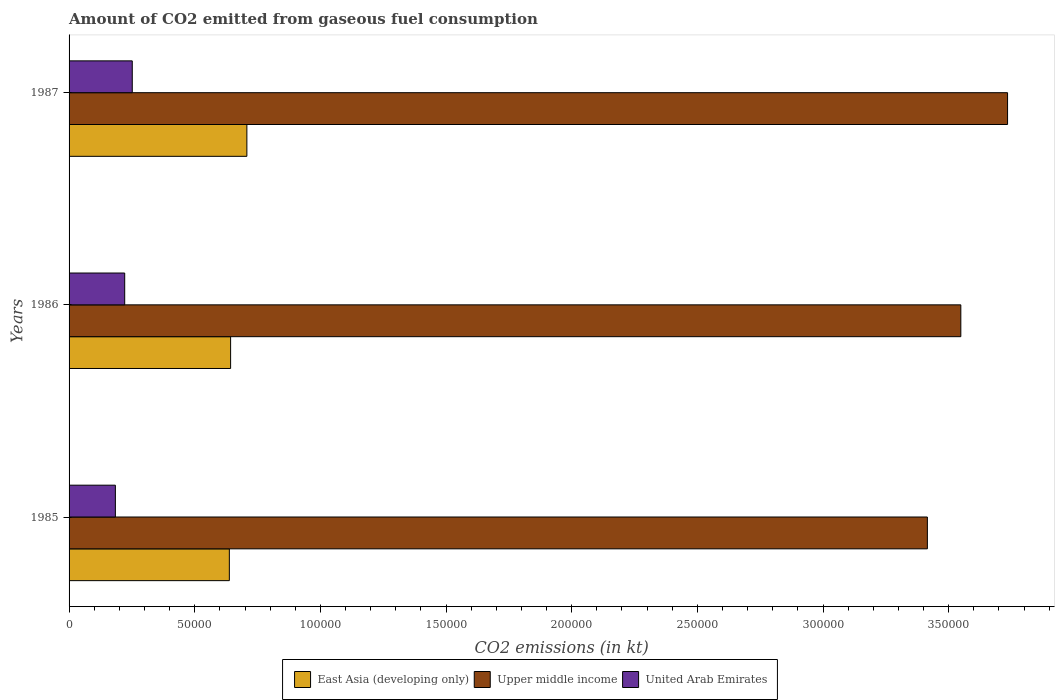How many groups of bars are there?
Make the answer very short. 3. Are the number of bars per tick equal to the number of legend labels?
Your response must be concise. Yes. How many bars are there on the 1st tick from the top?
Your answer should be very brief. 3. What is the label of the 2nd group of bars from the top?
Ensure brevity in your answer.  1986. In how many cases, is the number of bars for a given year not equal to the number of legend labels?
Provide a short and direct response. 0. What is the amount of CO2 emitted in East Asia (developing only) in 1987?
Provide a succinct answer. 7.07e+04. Across all years, what is the maximum amount of CO2 emitted in Upper middle income?
Your response must be concise. 3.73e+05. Across all years, what is the minimum amount of CO2 emitted in East Asia (developing only)?
Give a very brief answer. 6.38e+04. In which year was the amount of CO2 emitted in East Asia (developing only) maximum?
Provide a succinct answer. 1987. In which year was the amount of CO2 emitted in East Asia (developing only) minimum?
Your answer should be compact. 1985. What is the total amount of CO2 emitted in Upper middle income in the graph?
Your response must be concise. 1.07e+06. What is the difference between the amount of CO2 emitted in United Arab Emirates in 1986 and that in 1987?
Your response must be concise. -3006.94. What is the difference between the amount of CO2 emitted in Upper middle income in 1985 and the amount of CO2 emitted in United Arab Emirates in 1986?
Make the answer very short. 3.19e+05. What is the average amount of CO2 emitted in United Arab Emirates per year?
Offer a terse response. 2.19e+04. In the year 1987, what is the difference between the amount of CO2 emitted in United Arab Emirates and amount of CO2 emitted in Upper middle income?
Give a very brief answer. -3.48e+05. What is the ratio of the amount of CO2 emitted in East Asia (developing only) in 1985 to that in 1986?
Ensure brevity in your answer.  0.99. Is the difference between the amount of CO2 emitted in United Arab Emirates in 1986 and 1987 greater than the difference between the amount of CO2 emitted in Upper middle income in 1986 and 1987?
Your answer should be very brief. Yes. What is the difference between the highest and the second highest amount of CO2 emitted in East Asia (developing only)?
Provide a short and direct response. 6475.14. What is the difference between the highest and the lowest amount of CO2 emitted in East Asia (developing only)?
Provide a short and direct response. 6977.23. Is the sum of the amount of CO2 emitted in Upper middle income in 1985 and 1986 greater than the maximum amount of CO2 emitted in United Arab Emirates across all years?
Offer a very short reply. Yes. What does the 1st bar from the top in 1987 represents?
Offer a very short reply. United Arab Emirates. What does the 1st bar from the bottom in 1987 represents?
Offer a terse response. East Asia (developing only). Is it the case that in every year, the sum of the amount of CO2 emitted in East Asia (developing only) and amount of CO2 emitted in Upper middle income is greater than the amount of CO2 emitted in United Arab Emirates?
Offer a terse response. Yes. How many years are there in the graph?
Your answer should be compact. 3. What is the difference between two consecutive major ticks on the X-axis?
Provide a succinct answer. 5.00e+04. Are the values on the major ticks of X-axis written in scientific E-notation?
Ensure brevity in your answer.  No. Does the graph contain any zero values?
Your response must be concise. No. How many legend labels are there?
Keep it short and to the point. 3. What is the title of the graph?
Give a very brief answer. Amount of CO2 emitted from gaseous fuel consumption. What is the label or title of the X-axis?
Your answer should be very brief. CO2 emissions (in kt). What is the label or title of the Y-axis?
Give a very brief answer. Years. What is the CO2 emissions (in kt) in East Asia (developing only) in 1985?
Your answer should be compact. 6.38e+04. What is the CO2 emissions (in kt) in Upper middle income in 1985?
Offer a terse response. 3.42e+05. What is the CO2 emissions (in kt) of United Arab Emirates in 1985?
Provide a succinct answer. 1.84e+04. What is the CO2 emissions (in kt) of East Asia (developing only) in 1986?
Provide a succinct answer. 6.43e+04. What is the CO2 emissions (in kt) in Upper middle income in 1986?
Provide a succinct answer. 3.55e+05. What is the CO2 emissions (in kt) of United Arab Emirates in 1986?
Ensure brevity in your answer.  2.21e+04. What is the CO2 emissions (in kt) of East Asia (developing only) in 1987?
Keep it short and to the point. 7.07e+04. What is the CO2 emissions (in kt) in Upper middle income in 1987?
Give a very brief answer. 3.73e+05. What is the CO2 emissions (in kt) of United Arab Emirates in 1987?
Your response must be concise. 2.51e+04. Across all years, what is the maximum CO2 emissions (in kt) in East Asia (developing only)?
Ensure brevity in your answer.  7.07e+04. Across all years, what is the maximum CO2 emissions (in kt) in Upper middle income?
Make the answer very short. 3.73e+05. Across all years, what is the maximum CO2 emissions (in kt) in United Arab Emirates?
Offer a terse response. 2.51e+04. Across all years, what is the minimum CO2 emissions (in kt) in East Asia (developing only)?
Ensure brevity in your answer.  6.38e+04. Across all years, what is the minimum CO2 emissions (in kt) of Upper middle income?
Offer a very short reply. 3.42e+05. Across all years, what is the minimum CO2 emissions (in kt) of United Arab Emirates?
Provide a short and direct response. 1.84e+04. What is the total CO2 emissions (in kt) of East Asia (developing only) in the graph?
Your answer should be very brief. 1.99e+05. What is the total CO2 emissions (in kt) in Upper middle income in the graph?
Offer a very short reply. 1.07e+06. What is the total CO2 emissions (in kt) in United Arab Emirates in the graph?
Give a very brief answer. 6.57e+04. What is the difference between the CO2 emissions (in kt) in East Asia (developing only) in 1985 and that in 1986?
Give a very brief answer. -502.09. What is the difference between the CO2 emissions (in kt) in Upper middle income in 1985 and that in 1986?
Provide a succinct answer. -1.33e+04. What is the difference between the CO2 emissions (in kt) in United Arab Emirates in 1985 and that in 1986?
Keep it short and to the point. -3714.67. What is the difference between the CO2 emissions (in kt) of East Asia (developing only) in 1985 and that in 1987?
Make the answer very short. -6977.23. What is the difference between the CO2 emissions (in kt) of Upper middle income in 1985 and that in 1987?
Provide a short and direct response. -3.19e+04. What is the difference between the CO2 emissions (in kt) of United Arab Emirates in 1985 and that in 1987?
Provide a short and direct response. -6721.61. What is the difference between the CO2 emissions (in kt) in East Asia (developing only) in 1986 and that in 1987?
Offer a terse response. -6475.14. What is the difference between the CO2 emissions (in kt) of Upper middle income in 1986 and that in 1987?
Give a very brief answer. -1.86e+04. What is the difference between the CO2 emissions (in kt) in United Arab Emirates in 1986 and that in 1987?
Provide a succinct answer. -3006.94. What is the difference between the CO2 emissions (in kt) of East Asia (developing only) in 1985 and the CO2 emissions (in kt) of Upper middle income in 1986?
Keep it short and to the point. -2.91e+05. What is the difference between the CO2 emissions (in kt) of East Asia (developing only) in 1985 and the CO2 emissions (in kt) of United Arab Emirates in 1986?
Offer a very short reply. 4.16e+04. What is the difference between the CO2 emissions (in kt) in Upper middle income in 1985 and the CO2 emissions (in kt) in United Arab Emirates in 1986?
Provide a succinct answer. 3.19e+05. What is the difference between the CO2 emissions (in kt) in East Asia (developing only) in 1985 and the CO2 emissions (in kt) in Upper middle income in 1987?
Offer a terse response. -3.10e+05. What is the difference between the CO2 emissions (in kt) of East Asia (developing only) in 1985 and the CO2 emissions (in kt) of United Arab Emirates in 1987?
Offer a terse response. 3.86e+04. What is the difference between the CO2 emissions (in kt) of Upper middle income in 1985 and the CO2 emissions (in kt) of United Arab Emirates in 1987?
Provide a short and direct response. 3.16e+05. What is the difference between the CO2 emissions (in kt) of East Asia (developing only) in 1986 and the CO2 emissions (in kt) of Upper middle income in 1987?
Provide a short and direct response. -3.09e+05. What is the difference between the CO2 emissions (in kt) of East Asia (developing only) in 1986 and the CO2 emissions (in kt) of United Arab Emirates in 1987?
Offer a very short reply. 3.91e+04. What is the difference between the CO2 emissions (in kt) in Upper middle income in 1986 and the CO2 emissions (in kt) in United Arab Emirates in 1987?
Offer a very short reply. 3.30e+05. What is the average CO2 emissions (in kt) of East Asia (developing only) per year?
Ensure brevity in your answer.  6.63e+04. What is the average CO2 emissions (in kt) in Upper middle income per year?
Keep it short and to the point. 3.57e+05. What is the average CO2 emissions (in kt) in United Arab Emirates per year?
Keep it short and to the point. 2.19e+04. In the year 1985, what is the difference between the CO2 emissions (in kt) of East Asia (developing only) and CO2 emissions (in kt) of Upper middle income?
Provide a short and direct response. -2.78e+05. In the year 1985, what is the difference between the CO2 emissions (in kt) in East Asia (developing only) and CO2 emissions (in kt) in United Arab Emirates?
Keep it short and to the point. 4.53e+04. In the year 1985, what is the difference between the CO2 emissions (in kt) in Upper middle income and CO2 emissions (in kt) in United Arab Emirates?
Ensure brevity in your answer.  3.23e+05. In the year 1986, what is the difference between the CO2 emissions (in kt) in East Asia (developing only) and CO2 emissions (in kt) in Upper middle income?
Give a very brief answer. -2.91e+05. In the year 1986, what is the difference between the CO2 emissions (in kt) in East Asia (developing only) and CO2 emissions (in kt) in United Arab Emirates?
Provide a succinct answer. 4.21e+04. In the year 1986, what is the difference between the CO2 emissions (in kt) of Upper middle income and CO2 emissions (in kt) of United Arab Emirates?
Make the answer very short. 3.33e+05. In the year 1987, what is the difference between the CO2 emissions (in kt) of East Asia (developing only) and CO2 emissions (in kt) of Upper middle income?
Offer a very short reply. -3.03e+05. In the year 1987, what is the difference between the CO2 emissions (in kt) of East Asia (developing only) and CO2 emissions (in kt) of United Arab Emirates?
Provide a succinct answer. 4.56e+04. In the year 1987, what is the difference between the CO2 emissions (in kt) in Upper middle income and CO2 emissions (in kt) in United Arab Emirates?
Offer a very short reply. 3.48e+05. What is the ratio of the CO2 emissions (in kt) of East Asia (developing only) in 1985 to that in 1986?
Give a very brief answer. 0.99. What is the ratio of the CO2 emissions (in kt) of Upper middle income in 1985 to that in 1986?
Offer a very short reply. 0.96. What is the ratio of the CO2 emissions (in kt) in United Arab Emirates in 1985 to that in 1986?
Provide a succinct answer. 0.83. What is the ratio of the CO2 emissions (in kt) of East Asia (developing only) in 1985 to that in 1987?
Your answer should be compact. 0.9. What is the ratio of the CO2 emissions (in kt) in Upper middle income in 1985 to that in 1987?
Ensure brevity in your answer.  0.91. What is the ratio of the CO2 emissions (in kt) in United Arab Emirates in 1985 to that in 1987?
Your answer should be very brief. 0.73. What is the ratio of the CO2 emissions (in kt) of East Asia (developing only) in 1986 to that in 1987?
Provide a short and direct response. 0.91. What is the ratio of the CO2 emissions (in kt) in Upper middle income in 1986 to that in 1987?
Offer a very short reply. 0.95. What is the ratio of the CO2 emissions (in kt) in United Arab Emirates in 1986 to that in 1987?
Ensure brevity in your answer.  0.88. What is the difference between the highest and the second highest CO2 emissions (in kt) in East Asia (developing only)?
Your answer should be compact. 6475.14. What is the difference between the highest and the second highest CO2 emissions (in kt) in Upper middle income?
Provide a short and direct response. 1.86e+04. What is the difference between the highest and the second highest CO2 emissions (in kt) of United Arab Emirates?
Keep it short and to the point. 3006.94. What is the difference between the highest and the lowest CO2 emissions (in kt) of East Asia (developing only)?
Your answer should be compact. 6977.23. What is the difference between the highest and the lowest CO2 emissions (in kt) in Upper middle income?
Give a very brief answer. 3.19e+04. What is the difference between the highest and the lowest CO2 emissions (in kt) in United Arab Emirates?
Provide a short and direct response. 6721.61. 